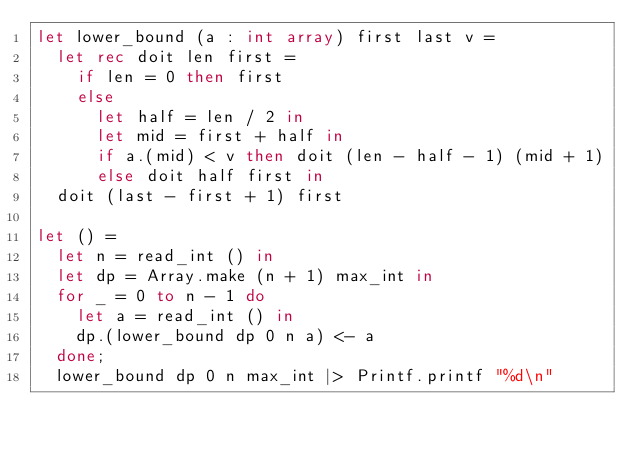Convert code to text. <code><loc_0><loc_0><loc_500><loc_500><_OCaml_>let lower_bound (a : int array) first last v =
  let rec doit len first =
    if len = 0 then first
    else
      let half = len / 2 in
      let mid = first + half in
      if a.(mid) < v then doit (len - half - 1) (mid + 1)
      else doit half first in
  doit (last - first + 1) first

let () =
  let n = read_int () in
  let dp = Array.make (n + 1) max_int in
  for _ = 0 to n - 1 do
    let a = read_int () in
    dp.(lower_bound dp 0 n a) <- a
  done;
  lower_bound dp 0 n max_int |> Printf.printf "%d\n"</code> 